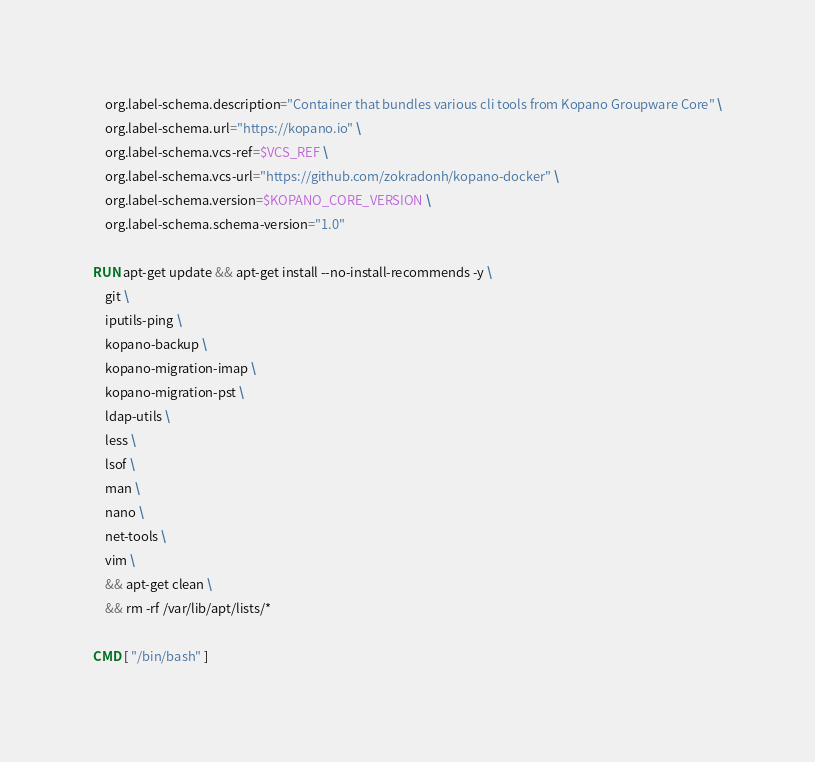<code> <loc_0><loc_0><loc_500><loc_500><_Dockerfile_>    org.label-schema.description="Container that bundles various cli tools from Kopano Groupware Core" \
    org.label-schema.url="https://kopano.io" \
    org.label-schema.vcs-ref=$VCS_REF \
    org.label-schema.vcs-url="https://github.com/zokradonh/kopano-docker" \
    org.label-schema.version=$KOPANO_CORE_VERSION \
    org.label-schema.schema-version="1.0"

RUN apt-get update && apt-get install --no-install-recommends -y \
    git \
    iputils-ping \
    kopano-backup \
    kopano-migration-imap \
    kopano-migration-pst \
    ldap-utils \
    less \
    lsof \
    man \
    nano \
    net-tools \
    vim \
    && apt-get clean \
    && rm -rf /var/lib/apt/lists/*

CMD [ "/bin/bash" ]
</code> 